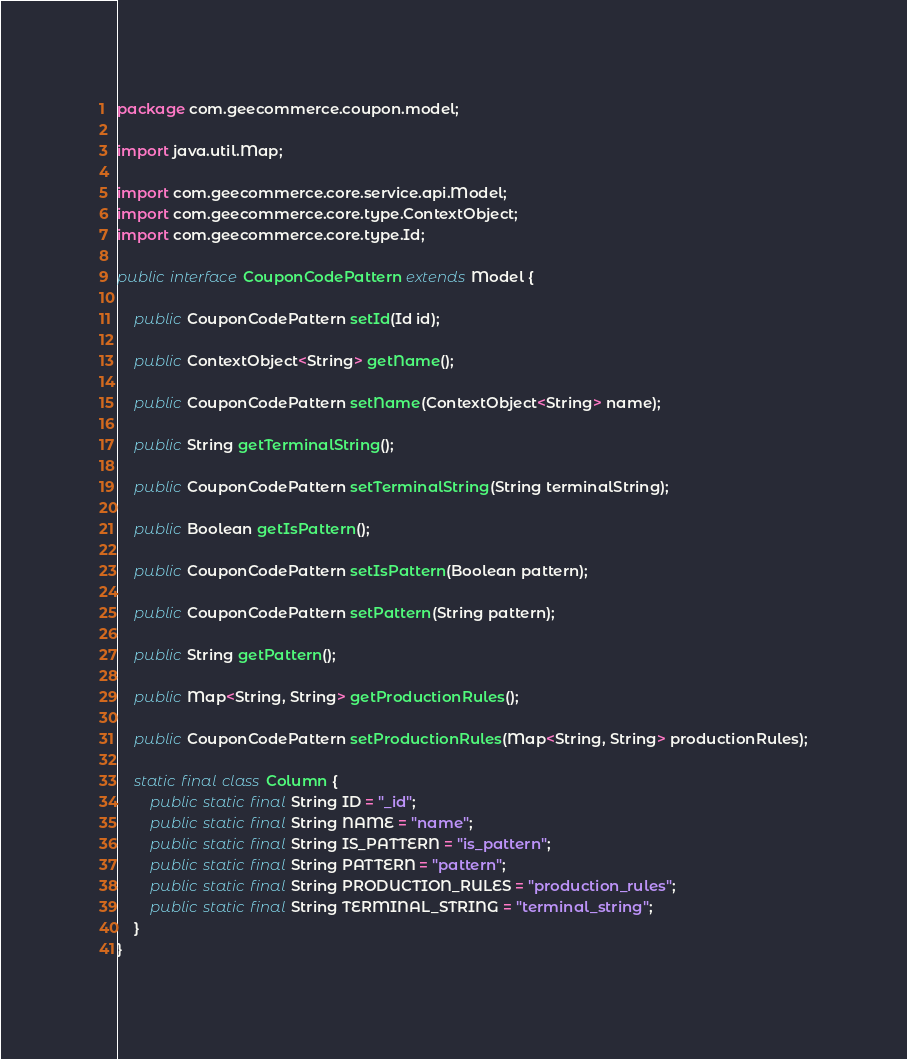Convert code to text. <code><loc_0><loc_0><loc_500><loc_500><_Java_>package com.geecommerce.coupon.model;

import java.util.Map;

import com.geecommerce.core.service.api.Model;
import com.geecommerce.core.type.ContextObject;
import com.geecommerce.core.type.Id;

public interface CouponCodePattern extends Model {

    public CouponCodePattern setId(Id id);

    public ContextObject<String> getName();

    public CouponCodePattern setName(ContextObject<String> name);

    public String getTerminalString();

    public CouponCodePattern setTerminalString(String terminalString);

    public Boolean getIsPattern();

    public CouponCodePattern setIsPattern(Boolean pattern);

    public CouponCodePattern setPattern(String pattern);

    public String getPattern();

    public Map<String, String> getProductionRules();

    public CouponCodePattern setProductionRules(Map<String, String> productionRules);

    static final class Column {
        public static final String ID = "_id";
        public static final String NAME = "name";
        public static final String IS_PATTERN = "is_pattern";
        public static final String PATTERN = "pattern";
        public static final String PRODUCTION_RULES = "production_rules";
        public static final String TERMINAL_STRING = "terminal_string";
    }
}
</code> 